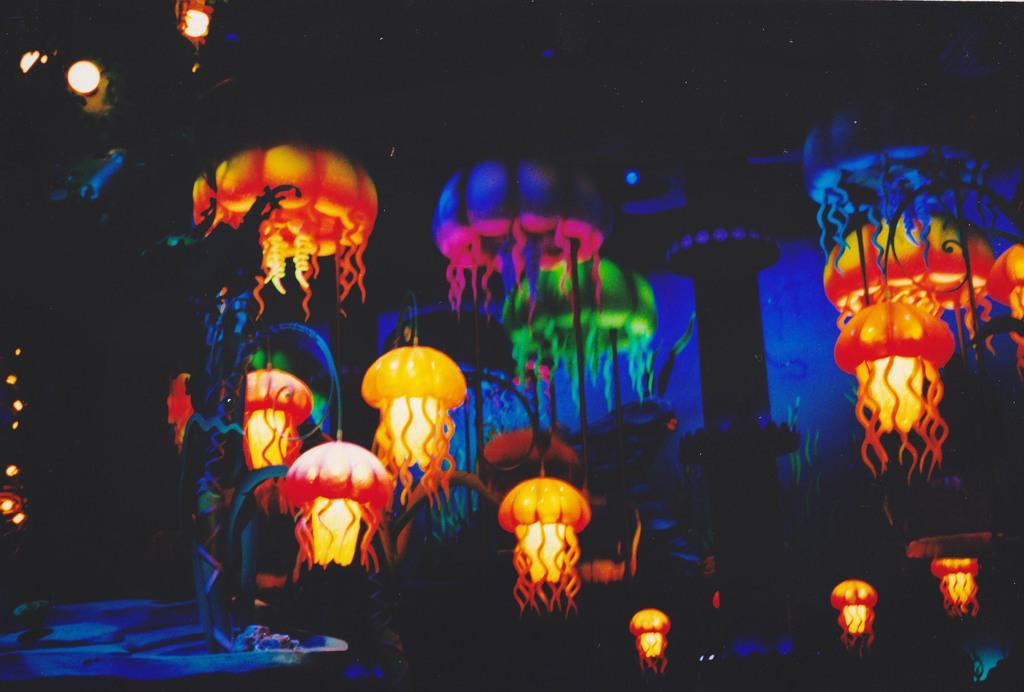What type of objects are present in the image? There are sky lanterns in the image. Can you describe the appearance of the sky lanterns? Sky lanterns are typically small, paper-like structures with a small fire source at the bottom, which allows them to float and light up the sky. What type of thing is the sun doing in the image? There is no sun present in the image; it only features sky lanterns. Can you describe the face on the sky lanterns in the image? There are no faces on the sky lanterns in the image; they are simple, paper-like structures without any facial features. 